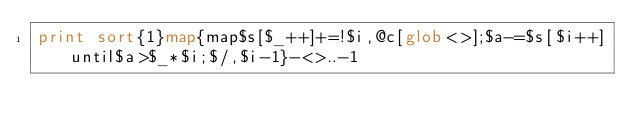<code> <loc_0><loc_0><loc_500><loc_500><_Perl_>print sort{1}map{map$s[$_++]+=!$i,@c[glob<>];$a-=$s[$i++]until$a>$_*$i;$/,$i-1}-<>..-1</code> 